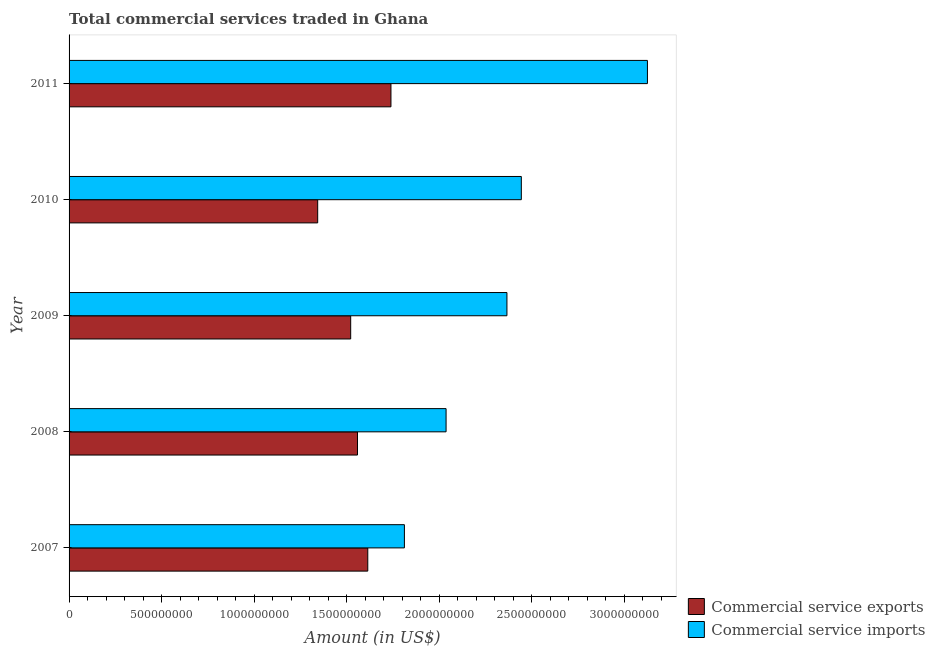Are the number of bars per tick equal to the number of legend labels?
Offer a very short reply. Yes. Are the number of bars on each tick of the Y-axis equal?
Keep it short and to the point. Yes. How many bars are there on the 1st tick from the top?
Offer a terse response. 2. In how many cases, is the number of bars for a given year not equal to the number of legend labels?
Ensure brevity in your answer.  0. What is the amount of commercial service exports in 2010?
Offer a very short reply. 1.34e+09. Across all years, what is the maximum amount of commercial service imports?
Your response must be concise. 3.13e+09. Across all years, what is the minimum amount of commercial service exports?
Keep it short and to the point. 1.34e+09. In which year was the amount of commercial service imports maximum?
Provide a succinct answer. 2011. What is the total amount of commercial service exports in the graph?
Offer a very short reply. 7.78e+09. What is the difference between the amount of commercial service exports in 2009 and that in 2010?
Ensure brevity in your answer.  1.78e+08. What is the difference between the amount of commercial service imports in 2008 and the amount of commercial service exports in 2007?
Ensure brevity in your answer.  4.23e+08. What is the average amount of commercial service exports per year?
Make the answer very short. 1.56e+09. In the year 2007, what is the difference between the amount of commercial service imports and amount of commercial service exports?
Your response must be concise. 1.98e+08. What is the ratio of the amount of commercial service exports in 2008 to that in 2010?
Your response must be concise. 1.16. Is the difference between the amount of commercial service exports in 2009 and 2010 greater than the difference between the amount of commercial service imports in 2009 and 2010?
Give a very brief answer. Yes. What is the difference between the highest and the second highest amount of commercial service exports?
Give a very brief answer. 1.25e+08. What is the difference between the highest and the lowest amount of commercial service imports?
Keep it short and to the point. 1.31e+09. In how many years, is the amount of commercial service exports greater than the average amount of commercial service exports taken over all years?
Offer a terse response. 3. What does the 1st bar from the top in 2010 represents?
Your response must be concise. Commercial service imports. What does the 1st bar from the bottom in 2011 represents?
Your response must be concise. Commercial service exports. Are the values on the major ticks of X-axis written in scientific E-notation?
Offer a terse response. No. Does the graph contain grids?
Keep it short and to the point. No. Where does the legend appear in the graph?
Keep it short and to the point. Bottom right. What is the title of the graph?
Offer a very short reply. Total commercial services traded in Ghana. What is the label or title of the X-axis?
Ensure brevity in your answer.  Amount (in US$). What is the label or title of the Y-axis?
Keep it short and to the point. Year. What is the Amount (in US$) in Commercial service exports in 2007?
Provide a succinct answer. 1.61e+09. What is the Amount (in US$) in Commercial service imports in 2007?
Provide a succinct answer. 1.81e+09. What is the Amount (in US$) in Commercial service exports in 2008?
Provide a short and direct response. 1.56e+09. What is the Amount (in US$) in Commercial service imports in 2008?
Keep it short and to the point. 2.04e+09. What is the Amount (in US$) of Commercial service exports in 2009?
Provide a short and direct response. 1.52e+09. What is the Amount (in US$) of Commercial service imports in 2009?
Make the answer very short. 2.37e+09. What is the Amount (in US$) in Commercial service exports in 2010?
Your answer should be very brief. 1.34e+09. What is the Amount (in US$) in Commercial service imports in 2010?
Make the answer very short. 2.44e+09. What is the Amount (in US$) in Commercial service exports in 2011?
Your answer should be compact. 1.74e+09. What is the Amount (in US$) of Commercial service imports in 2011?
Your response must be concise. 3.13e+09. Across all years, what is the maximum Amount (in US$) in Commercial service exports?
Provide a short and direct response. 1.74e+09. Across all years, what is the maximum Amount (in US$) of Commercial service imports?
Give a very brief answer. 3.13e+09. Across all years, what is the minimum Amount (in US$) of Commercial service exports?
Your answer should be compact. 1.34e+09. Across all years, what is the minimum Amount (in US$) of Commercial service imports?
Make the answer very short. 1.81e+09. What is the total Amount (in US$) in Commercial service exports in the graph?
Give a very brief answer. 7.78e+09. What is the total Amount (in US$) of Commercial service imports in the graph?
Provide a short and direct response. 1.18e+1. What is the difference between the Amount (in US$) of Commercial service exports in 2007 and that in 2008?
Provide a short and direct response. 5.56e+07. What is the difference between the Amount (in US$) in Commercial service imports in 2007 and that in 2008?
Offer a terse response. -2.25e+08. What is the difference between the Amount (in US$) of Commercial service exports in 2007 and that in 2009?
Provide a short and direct response. 9.24e+07. What is the difference between the Amount (in US$) of Commercial service imports in 2007 and that in 2009?
Your answer should be very brief. -5.54e+08. What is the difference between the Amount (in US$) in Commercial service exports in 2007 and that in 2010?
Ensure brevity in your answer.  2.71e+08. What is the difference between the Amount (in US$) in Commercial service imports in 2007 and that in 2010?
Your answer should be compact. -6.32e+08. What is the difference between the Amount (in US$) of Commercial service exports in 2007 and that in 2011?
Your response must be concise. -1.25e+08. What is the difference between the Amount (in US$) in Commercial service imports in 2007 and that in 2011?
Your response must be concise. -1.31e+09. What is the difference between the Amount (in US$) in Commercial service exports in 2008 and that in 2009?
Your answer should be compact. 3.67e+07. What is the difference between the Amount (in US$) in Commercial service imports in 2008 and that in 2009?
Give a very brief answer. -3.29e+08. What is the difference between the Amount (in US$) in Commercial service exports in 2008 and that in 2010?
Offer a very short reply. 2.15e+08. What is the difference between the Amount (in US$) of Commercial service imports in 2008 and that in 2010?
Provide a short and direct response. -4.07e+08. What is the difference between the Amount (in US$) of Commercial service exports in 2008 and that in 2011?
Provide a succinct answer. -1.81e+08. What is the difference between the Amount (in US$) of Commercial service imports in 2008 and that in 2011?
Offer a terse response. -1.09e+09. What is the difference between the Amount (in US$) in Commercial service exports in 2009 and that in 2010?
Keep it short and to the point. 1.78e+08. What is the difference between the Amount (in US$) in Commercial service imports in 2009 and that in 2010?
Your answer should be compact. -7.78e+07. What is the difference between the Amount (in US$) in Commercial service exports in 2009 and that in 2011?
Make the answer very short. -2.18e+08. What is the difference between the Amount (in US$) of Commercial service imports in 2009 and that in 2011?
Make the answer very short. -7.59e+08. What is the difference between the Amount (in US$) in Commercial service exports in 2010 and that in 2011?
Provide a succinct answer. -3.96e+08. What is the difference between the Amount (in US$) of Commercial service imports in 2010 and that in 2011?
Make the answer very short. -6.82e+08. What is the difference between the Amount (in US$) in Commercial service exports in 2007 and the Amount (in US$) in Commercial service imports in 2008?
Your answer should be compact. -4.23e+08. What is the difference between the Amount (in US$) in Commercial service exports in 2007 and the Amount (in US$) in Commercial service imports in 2009?
Ensure brevity in your answer.  -7.52e+08. What is the difference between the Amount (in US$) in Commercial service exports in 2007 and the Amount (in US$) in Commercial service imports in 2010?
Ensure brevity in your answer.  -8.30e+08. What is the difference between the Amount (in US$) of Commercial service exports in 2007 and the Amount (in US$) of Commercial service imports in 2011?
Make the answer very short. -1.51e+09. What is the difference between the Amount (in US$) of Commercial service exports in 2008 and the Amount (in US$) of Commercial service imports in 2009?
Ensure brevity in your answer.  -8.08e+08. What is the difference between the Amount (in US$) in Commercial service exports in 2008 and the Amount (in US$) in Commercial service imports in 2010?
Your answer should be compact. -8.85e+08. What is the difference between the Amount (in US$) in Commercial service exports in 2008 and the Amount (in US$) in Commercial service imports in 2011?
Your answer should be compact. -1.57e+09. What is the difference between the Amount (in US$) in Commercial service exports in 2009 and the Amount (in US$) in Commercial service imports in 2010?
Your response must be concise. -9.22e+08. What is the difference between the Amount (in US$) of Commercial service exports in 2009 and the Amount (in US$) of Commercial service imports in 2011?
Your answer should be compact. -1.60e+09. What is the difference between the Amount (in US$) of Commercial service exports in 2010 and the Amount (in US$) of Commercial service imports in 2011?
Offer a very short reply. -1.78e+09. What is the average Amount (in US$) of Commercial service exports per year?
Offer a terse response. 1.56e+09. What is the average Amount (in US$) of Commercial service imports per year?
Provide a succinct answer. 2.36e+09. In the year 2007, what is the difference between the Amount (in US$) in Commercial service exports and Amount (in US$) in Commercial service imports?
Offer a terse response. -1.98e+08. In the year 2008, what is the difference between the Amount (in US$) in Commercial service exports and Amount (in US$) in Commercial service imports?
Make the answer very short. -4.79e+08. In the year 2009, what is the difference between the Amount (in US$) in Commercial service exports and Amount (in US$) in Commercial service imports?
Your response must be concise. -8.44e+08. In the year 2010, what is the difference between the Amount (in US$) in Commercial service exports and Amount (in US$) in Commercial service imports?
Provide a succinct answer. -1.10e+09. In the year 2011, what is the difference between the Amount (in US$) of Commercial service exports and Amount (in US$) of Commercial service imports?
Offer a very short reply. -1.39e+09. What is the ratio of the Amount (in US$) of Commercial service exports in 2007 to that in 2008?
Make the answer very short. 1.04. What is the ratio of the Amount (in US$) in Commercial service imports in 2007 to that in 2008?
Your answer should be compact. 0.89. What is the ratio of the Amount (in US$) in Commercial service exports in 2007 to that in 2009?
Offer a terse response. 1.06. What is the ratio of the Amount (in US$) of Commercial service imports in 2007 to that in 2009?
Your answer should be very brief. 0.77. What is the ratio of the Amount (in US$) of Commercial service exports in 2007 to that in 2010?
Provide a succinct answer. 1.2. What is the ratio of the Amount (in US$) in Commercial service imports in 2007 to that in 2010?
Your answer should be very brief. 0.74. What is the ratio of the Amount (in US$) of Commercial service exports in 2007 to that in 2011?
Offer a terse response. 0.93. What is the ratio of the Amount (in US$) of Commercial service imports in 2007 to that in 2011?
Offer a very short reply. 0.58. What is the ratio of the Amount (in US$) of Commercial service exports in 2008 to that in 2009?
Offer a very short reply. 1.02. What is the ratio of the Amount (in US$) of Commercial service imports in 2008 to that in 2009?
Keep it short and to the point. 0.86. What is the ratio of the Amount (in US$) of Commercial service exports in 2008 to that in 2010?
Ensure brevity in your answer.  1.16. What is the ratio of the Amount (in US$) of Commercial service imports in 2008 to that in 2010?
Provide a succinct answer. 0.83. What is the ratio of the Amount (in US$) of Commercial service exports in 2008 to that in 2011?
Your answer should be compact. 0.9. What is the ratio of the Amount (in US$) of Commercial service imports in 2008 to that in 2011?
Your answer should be very brief. 0.65. What is the ratio of the Amount (in US$) of Commercial service exports in 2009 to that in 2010?
Your answer should be compact. 1.13. What is the ratio of the Amount (in US$) of Commercial service imports in 2009 to that in 2010?
Offer a very short reply. 0.97. What is the ratio of the Amount (in US$) of Commercial service exports in 2009 to that in 2011?
Your response must be concise. 0.87. What is the ratio of the Amount (in US$) of Commercial service imports in 2009 to that in 2011?
Your answer should be very brief. 0.76. What is the ratio of the Amount (in US$) of Commercial service exports in 2010 to that in 2011?
Make the answer very short. 0.77. What is the ratio of the Amount (in US$) in Commercial service imports in 2010 to that in 2011?
Keep it short and to the point. 0.78. What is the difference between the highest and the second highest Amount (in US$) in Commercial service exports?
Offer a terse response. 1.25e+08. What is the difference between the highest and the second highest Amount (in US$) in Commercial service imports?
Keep it short and to the point. 6.82e+08. What is the difference between the highest and the lowest Amount (in US$) of Commercial service exports?
Ensure brevity in your answer.  3.96e+08. What is the difference between the highest and the lowest Amount (in US$) in Commercial service imports?
Keep it short and to the point. 1.31e+09. 